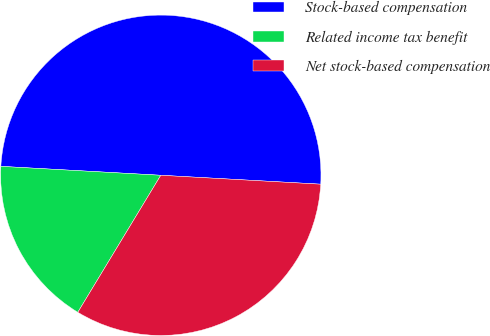<chart> <loc_0><loc_0><loc_500><loc_500><pie_chart><fcel>Stock-based compensation<fcel>Related income tax benefit<fcel>Net stock-based compensation<nl><fcel>50.0%<fcel>17.22%<fcel>32.78%<nl></chart> 